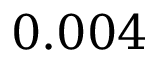Convert formula to latex. <formula><loc_0><loc_0><loc_500><loc_500>0 . 0 0 4</formula> 